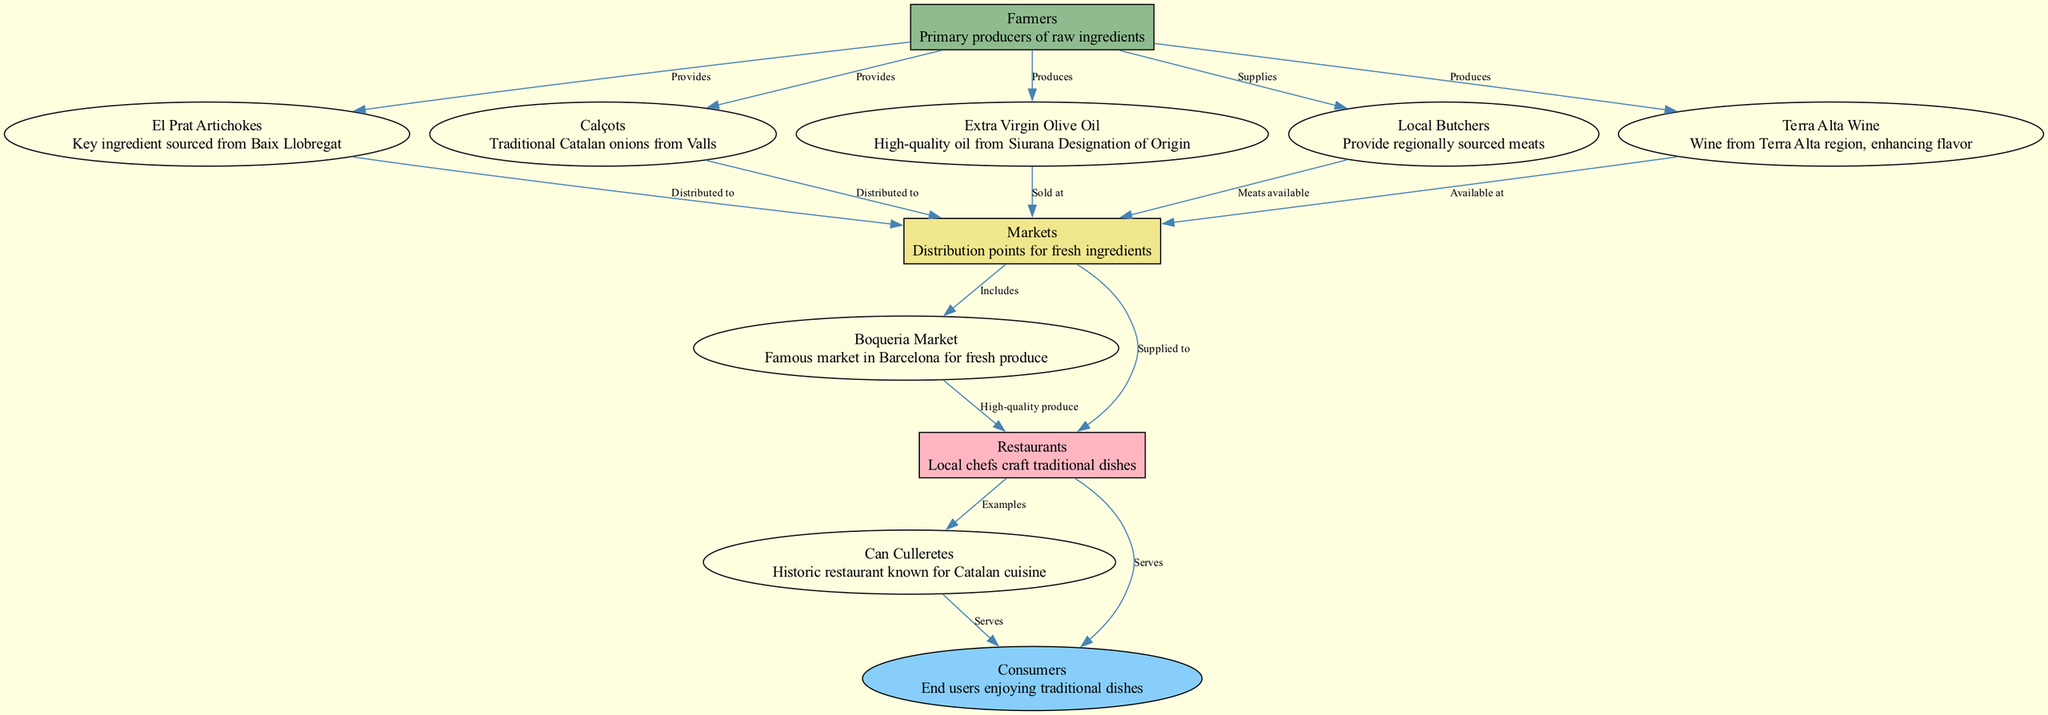What is the key ingredient sourced from Baix Llobregat? The diagram indicates that El Prat Artichokes are sourced from Baix Llobregat, as shown in the nodes and their descriptions.
Answer: El Prat Artichokes How many nodes are represented in the diagram? By counting the nodes listed in the data section, we find a total of 11 nodes representing different elements of the food chain.
Answer: 11 Who supplies regionally sourced meats? The description of the Local Butchers node indicates that they are the ones who provide regionally sourced meats, as shown by the relationship in the edges.
Answer: Local Butchers What market is famous for fresh produce in Barcelona? The edge leading to the Boqueria Market indicates that it is recognized for high-quality produce, confirming its fame in the area.
Answer: Boqueria Market Which node serves traditional dishes? The diagram shows that both Can Culleretes and Restaurants nodes have edges leading to Consumers, indicating they serve traditional Catalan dishes.
Answer: Can Culleretes, Restaurants What type of oil is produced from the farmers? The edges specify that Extra Virgin Olive Oil is produced by Farmers, as indicated in the nodes and descriptions provided.
Answer: Extra Virgin Olive Oil Which region does Terra Alta Wine come from? The node description for Terra Alta Wine specifies that it is sourced from the Terra Alta region, which is directly mentioned in the diagram.
Answer: Terra Alta region What do consumers enjoy at the end of the food chain? The Consumers node concludes the flow of the food chain, indicating that they enjoy traditional dishes prepared from the ingredients supplied through the earlier stages.
Answer: Traditional dishes 